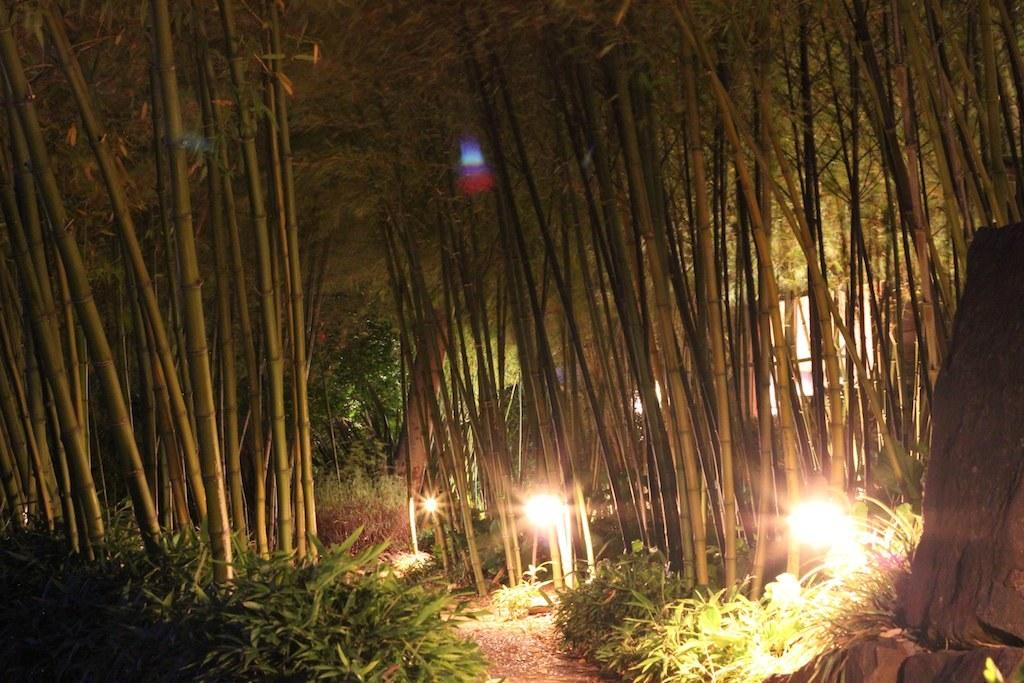What type of vegetation is present in the image? There is a plant and trees in the image. Can you describe any man-made objects in the image? There is a light and a trunk in the image. How many babies are sitting on the plant in the image? There are no babies present in the image; it features a plant, trees, a light, and a trunk. What type of pizza is being served on the trunk in the image? There is no pizza present in the image; it only contains a plant, trees, a light, and a trunk. 